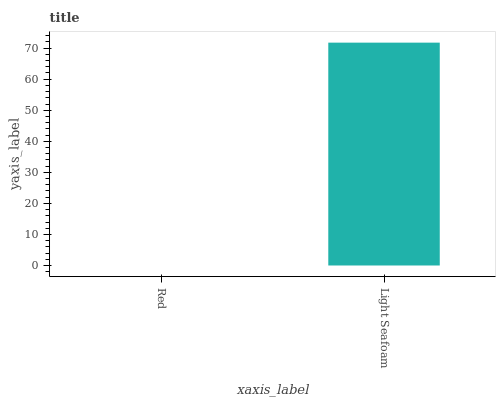Is Light Seafoam the minimum?
Answer yes or no. No. Is Light Seafoam greater than Red?
Answer yes or no. Yes. Is Red less than Light Seafoam?
Answer yes or no. Yes. Is Red greater than Light Seafoam?
Answer yes or no. No. Is Light Seafoam less than Red?
Answer yes or no. No. Is Light Seafoam the high median?
Answer yes or no. Yes. Is Red the low median?
Answer yes or no. Yes. Is Red the high median?
Answer yes or no. No. Is Light Seafoam the low median?
Answer yes or no. No. 